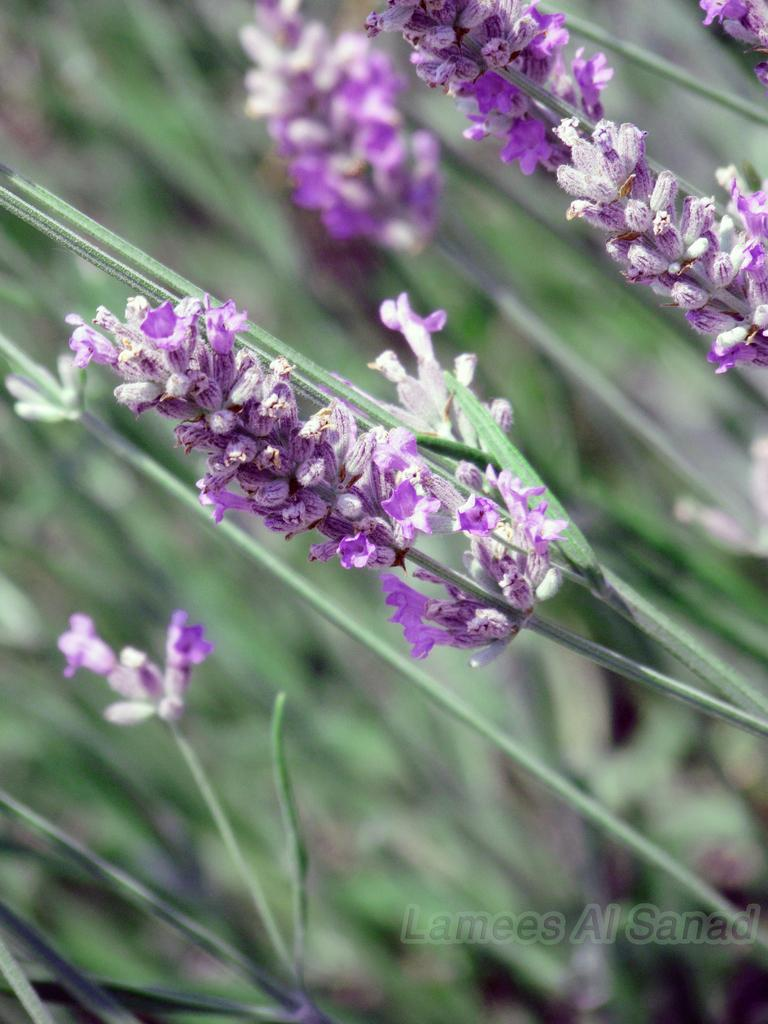What type of flowers are present in the image? There are violet color flowers with stems in the image. Can you describe the flowers' location in the image? The violet flowers are both in the foreground and background of the image. What color is the background of the image? The background of the image is green in color. What type of feather can be seen on the bread in the image? There is no bread or feather present in the image; it features violet flowers with stems and a green background. 